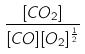<formula> <loc_0><loc_0><loc_500><loc_500>\frac { [ C O _ { 2 } ] } { [ C O ] [ O _ { 2 } ] ^ { \frac { 1 } { 2 } } }</formula> 